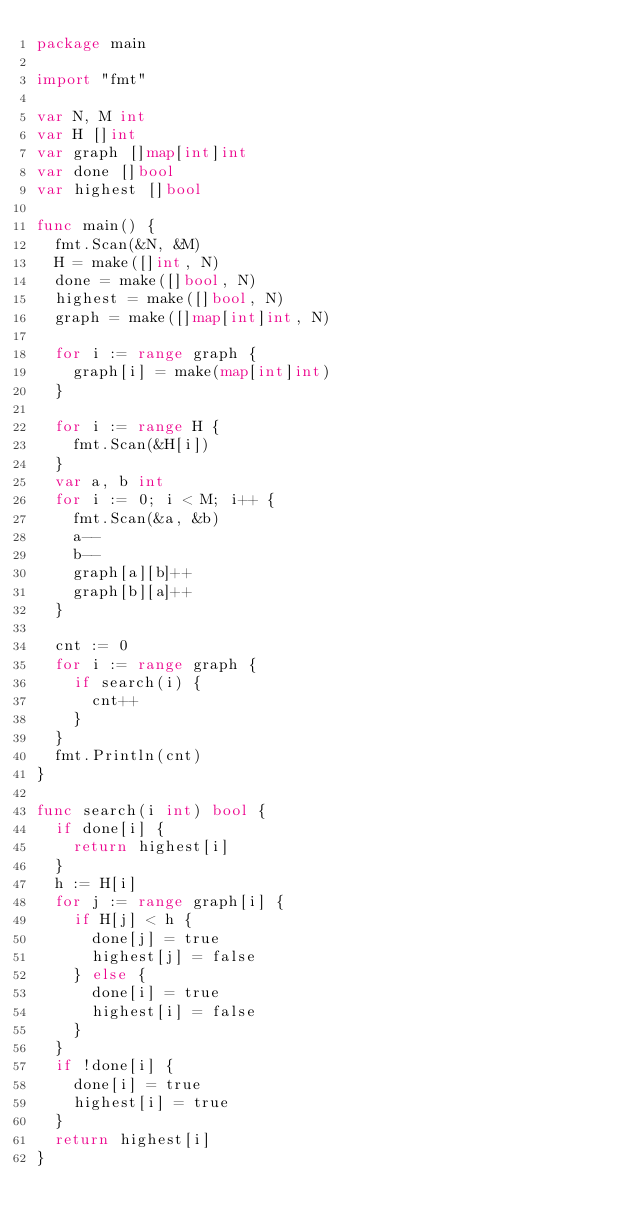Convert code to text. <code><loc_0><loc_0><loc_500><loc_500><_Go_>package main

import "fmt"

var N, M int
var H []int
var graph []map[int]int
var done []bool
var highest []bool

func main() {
	fmt.Scan(&N, &M)
	H = make([]int, N)
	done = make([]bool, N)
	highest = make([]bool, N)
	graph = make([]map[int]int, N)

	for i := range graph {
		graph[i] = make(map[int]int)
	}

	for i := range H {
		fmt.Scan(&H[i])
	}
	var a, b int
	for i := 0; i < M; i++ {
		fmt.Scan(&a, &b)
		a--
		b--
		graph[a][b]++
		graph[b][a]++
	}

	cnt := 0
	for i := range graph {
		if search(i) {
			cnt++
		}
	}
	fmt.Println(cnt)
}

func search(i int) bool {
	if done[i] {
		return highest[i]
	}
	h := H[i]
	for j := range graph[i] {
		if H[j] < h {
			done[j] = true
			highest[j] = false
		} else {
			done[i] = true
			highest[i] = false
		}
	}
	if !done[i] {
		done[i] = true
		highest[i] = true
	}
	return highest[i]
}
</code> 